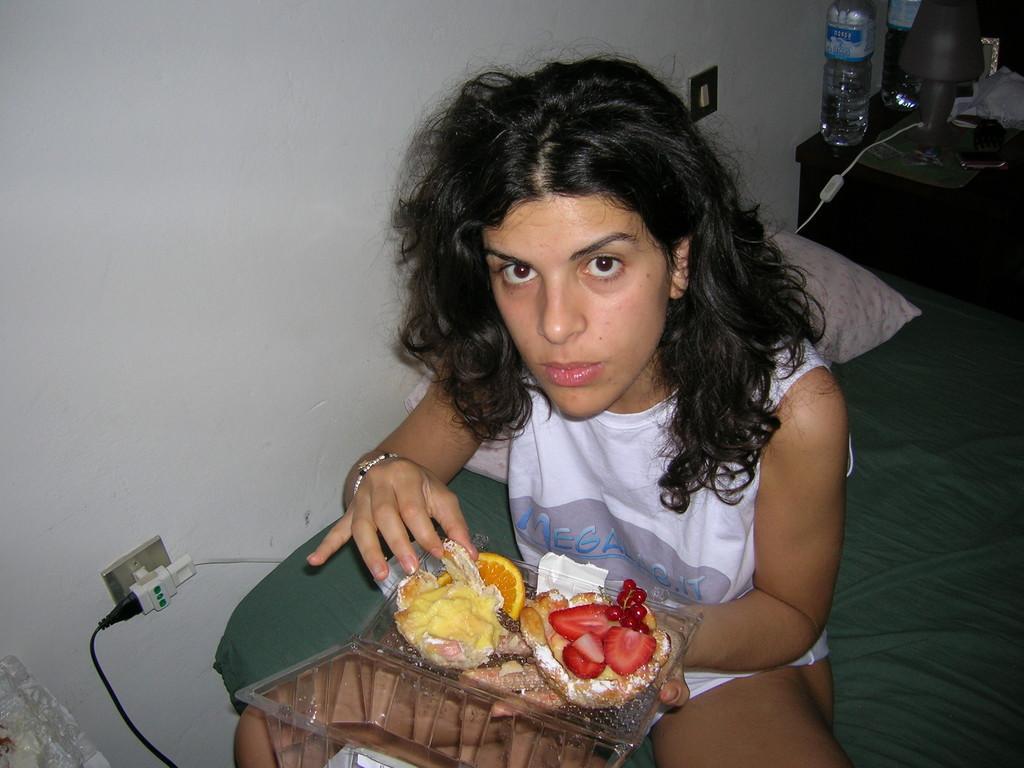Could you give a brief overview of what you see in this image? This is the picture of a room. In this image there is a woman sitting and holding the box, there are fruits in the box. At the back there is a pillow on the bed. There are bottles and there is a lamp and frame on the table. There are switch boards on the wall. 